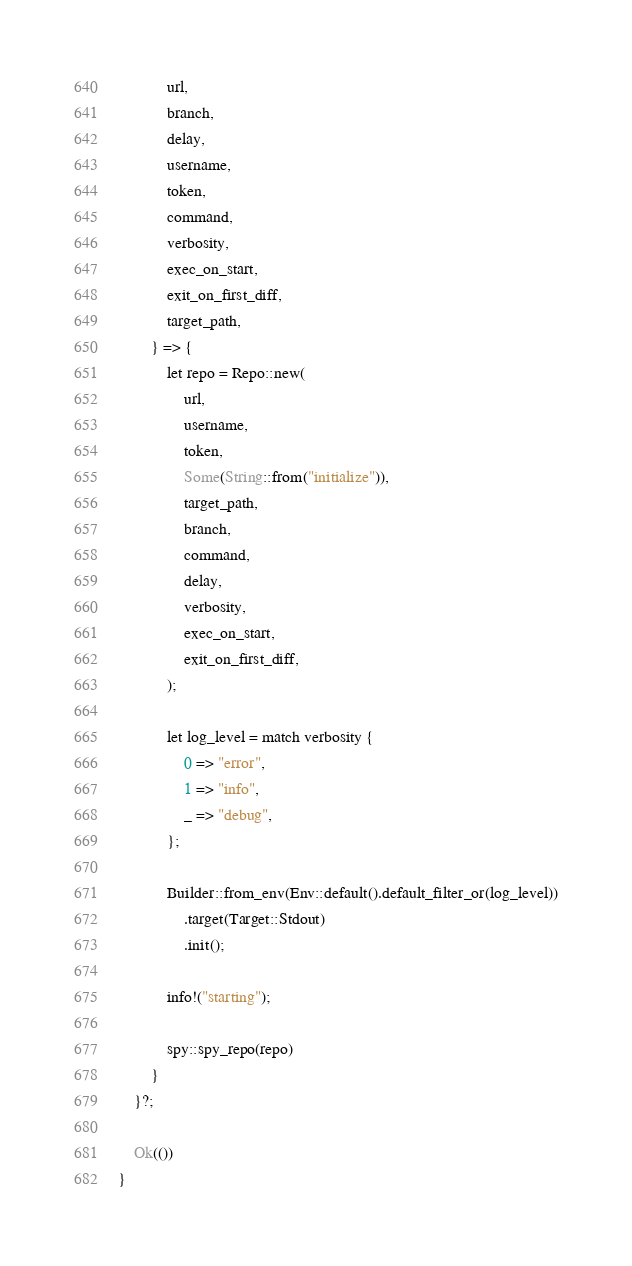<code> <loc_0><loc_0><loc_500><loc_500><_Rust_>            url,
            branch,
            delay,
            username,
            token,
            command,
            verbosity,
            exec_on_start,
            exit_on_first_diff,
            target_path,
        } => {
            let repo = Repo::new(
                url,
                username,
                token,
                Some(String::from("initialize")),
                target_path,
                branch,
                command,
                delay,
                verbosity,
                exec_on_start,
                exit_on_first_diff,
            );

            let log_level = match verbosity {
                0 => "error",
                1 => "info",
                _ => "debug",
            };

            Builder::from_env(Env::default().default_filter_or(log_level))
                .target(Target::Stdout)
                .init();

            info!("starting");

            spy::spy_repo(repo)
        }
    }?;

    Ok(())
}
</code> 